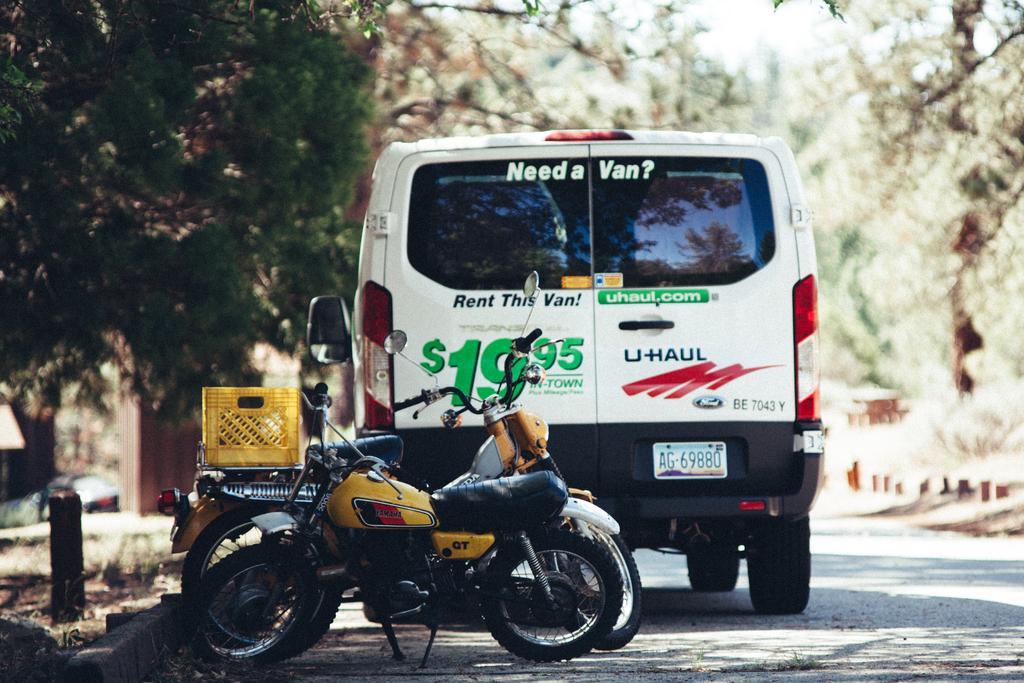In one or two sentences, can you explain what this image depicts? In the center of the image we can see a bike and one vehicle on the road. And we can see a basket on the bike. And we can see some text on the vehicle. In the background, we can see the sky, trees and a few other objects. 